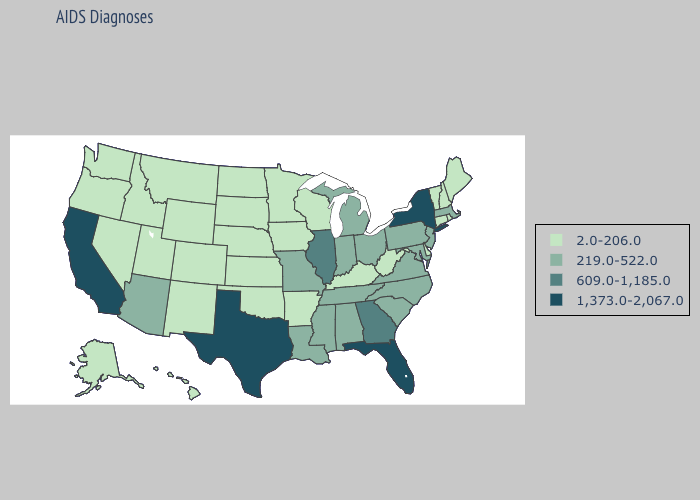Which states have the lowest value in the Northeast?
Concise answer only. Connecticut, Maine, New Hampshire, Rhode Island, Vermont. Does Montana have the lowest value in the West?
Be succinct. Yes. Does Pennsylvania have the lowest value in the Northeast?
Answer briefly. No. Among the states that border Wisconsin , does Illinois have the lowest value?
Concise answer only. No. What is the value of New Mexico?
Quick response, please. 2.0-206.0. How many symbols are there in the legend?
Concise answer only. 4. Among the states that border Nebraska , does Colorado have the lowest value?
Be succinct. Yes. What is the value of Montana?
Answer briefly. 2.0-206.0. What is the lowest value in states that border Texas?
Give a very brief answer. 2.0-206.0. What is the value of Minnesota?
Keep it brief. 2.0-206.0. What is the value of California?
Quick response, please. 1,373.0-2,067.0. What is the lowest value in the West?
Write a very short answer. 2.0-206.0. Name the states that have a value in the range 219.0-522.0?
Concise answer only. Alabama, Arizona, Indiana, Louisiana, Maryland, Massachusetts, Michigan, Mississippi, Missouri, New Jersey, North Carolina, Ohio, Pennsylvania, South Carolina, Tennessee, Virginia. What is the highest value in the Northeast ?
Answer briefly. 1,373.0-2,067.0. How many symbols are there in the legend?
Keep it brief. 4. 